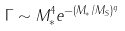<formula> <loc_0><loc_0><loc_500><loc_500>\Gamma \sim M _ { * } ^ { 4 } e ^ { - ( M _ { * } / M _ { S } ) ^ { q } }</formula> 